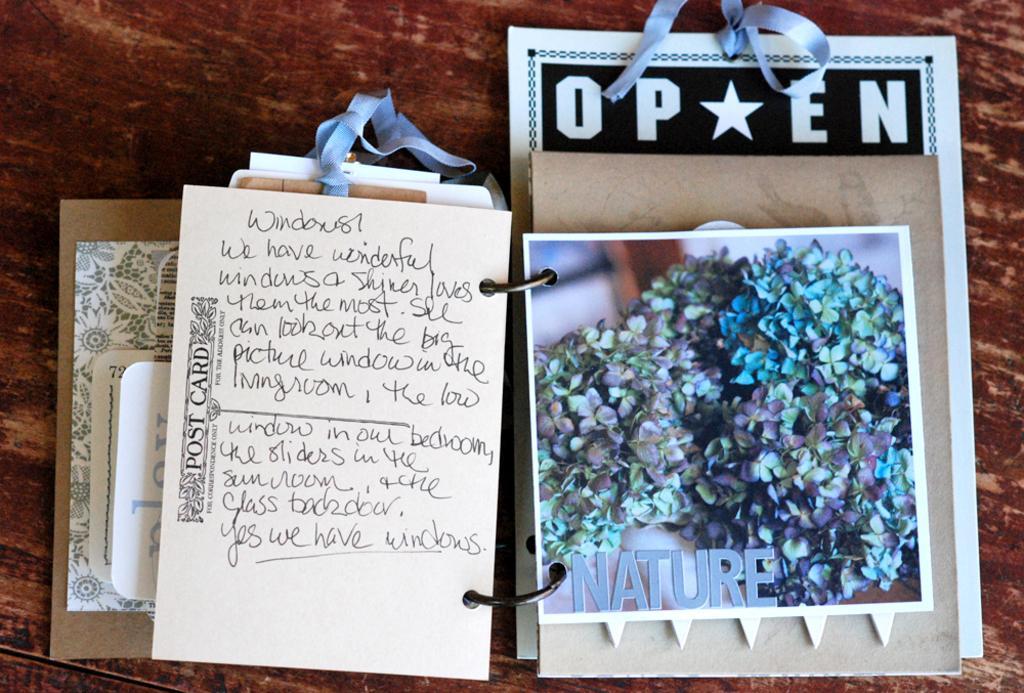Can you describe this image briefly? In the image we can see the wooden surface, on the wooden surface, we can see greetings and the text. 